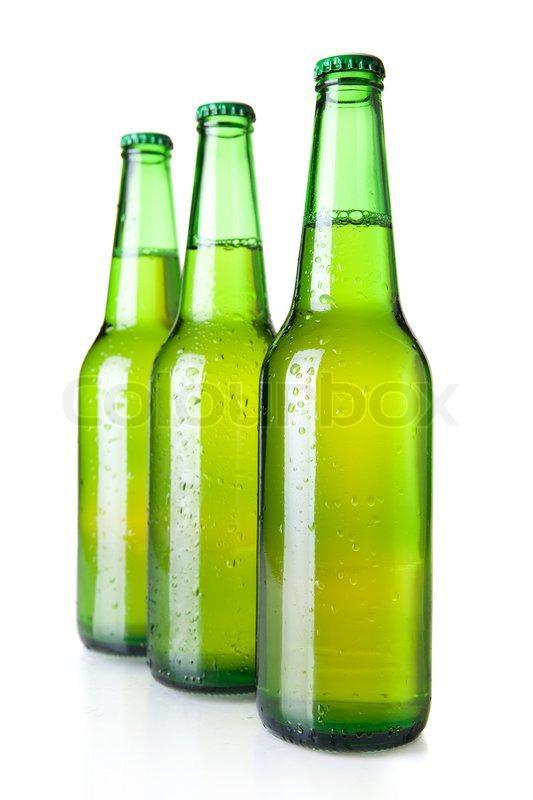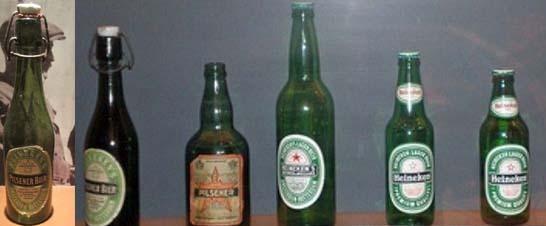The first image is the image on the left, the second image is the image on the right. For the images shown, is this caption "Three identical green bottles are standing in a row." true? Answer yes or no. Yes. 